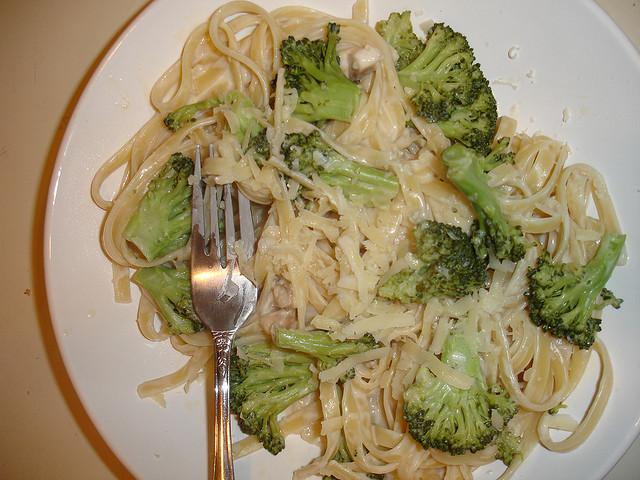What is the broccoli smothered in?
Write a very short answer. Noodles. Is this food healthy?
Concise answer only. Yes. What sauce is on this pasta?
Keep it brief. Alfredo. What vegetable is on the pasta?
Answer briefly. Broccoli. 